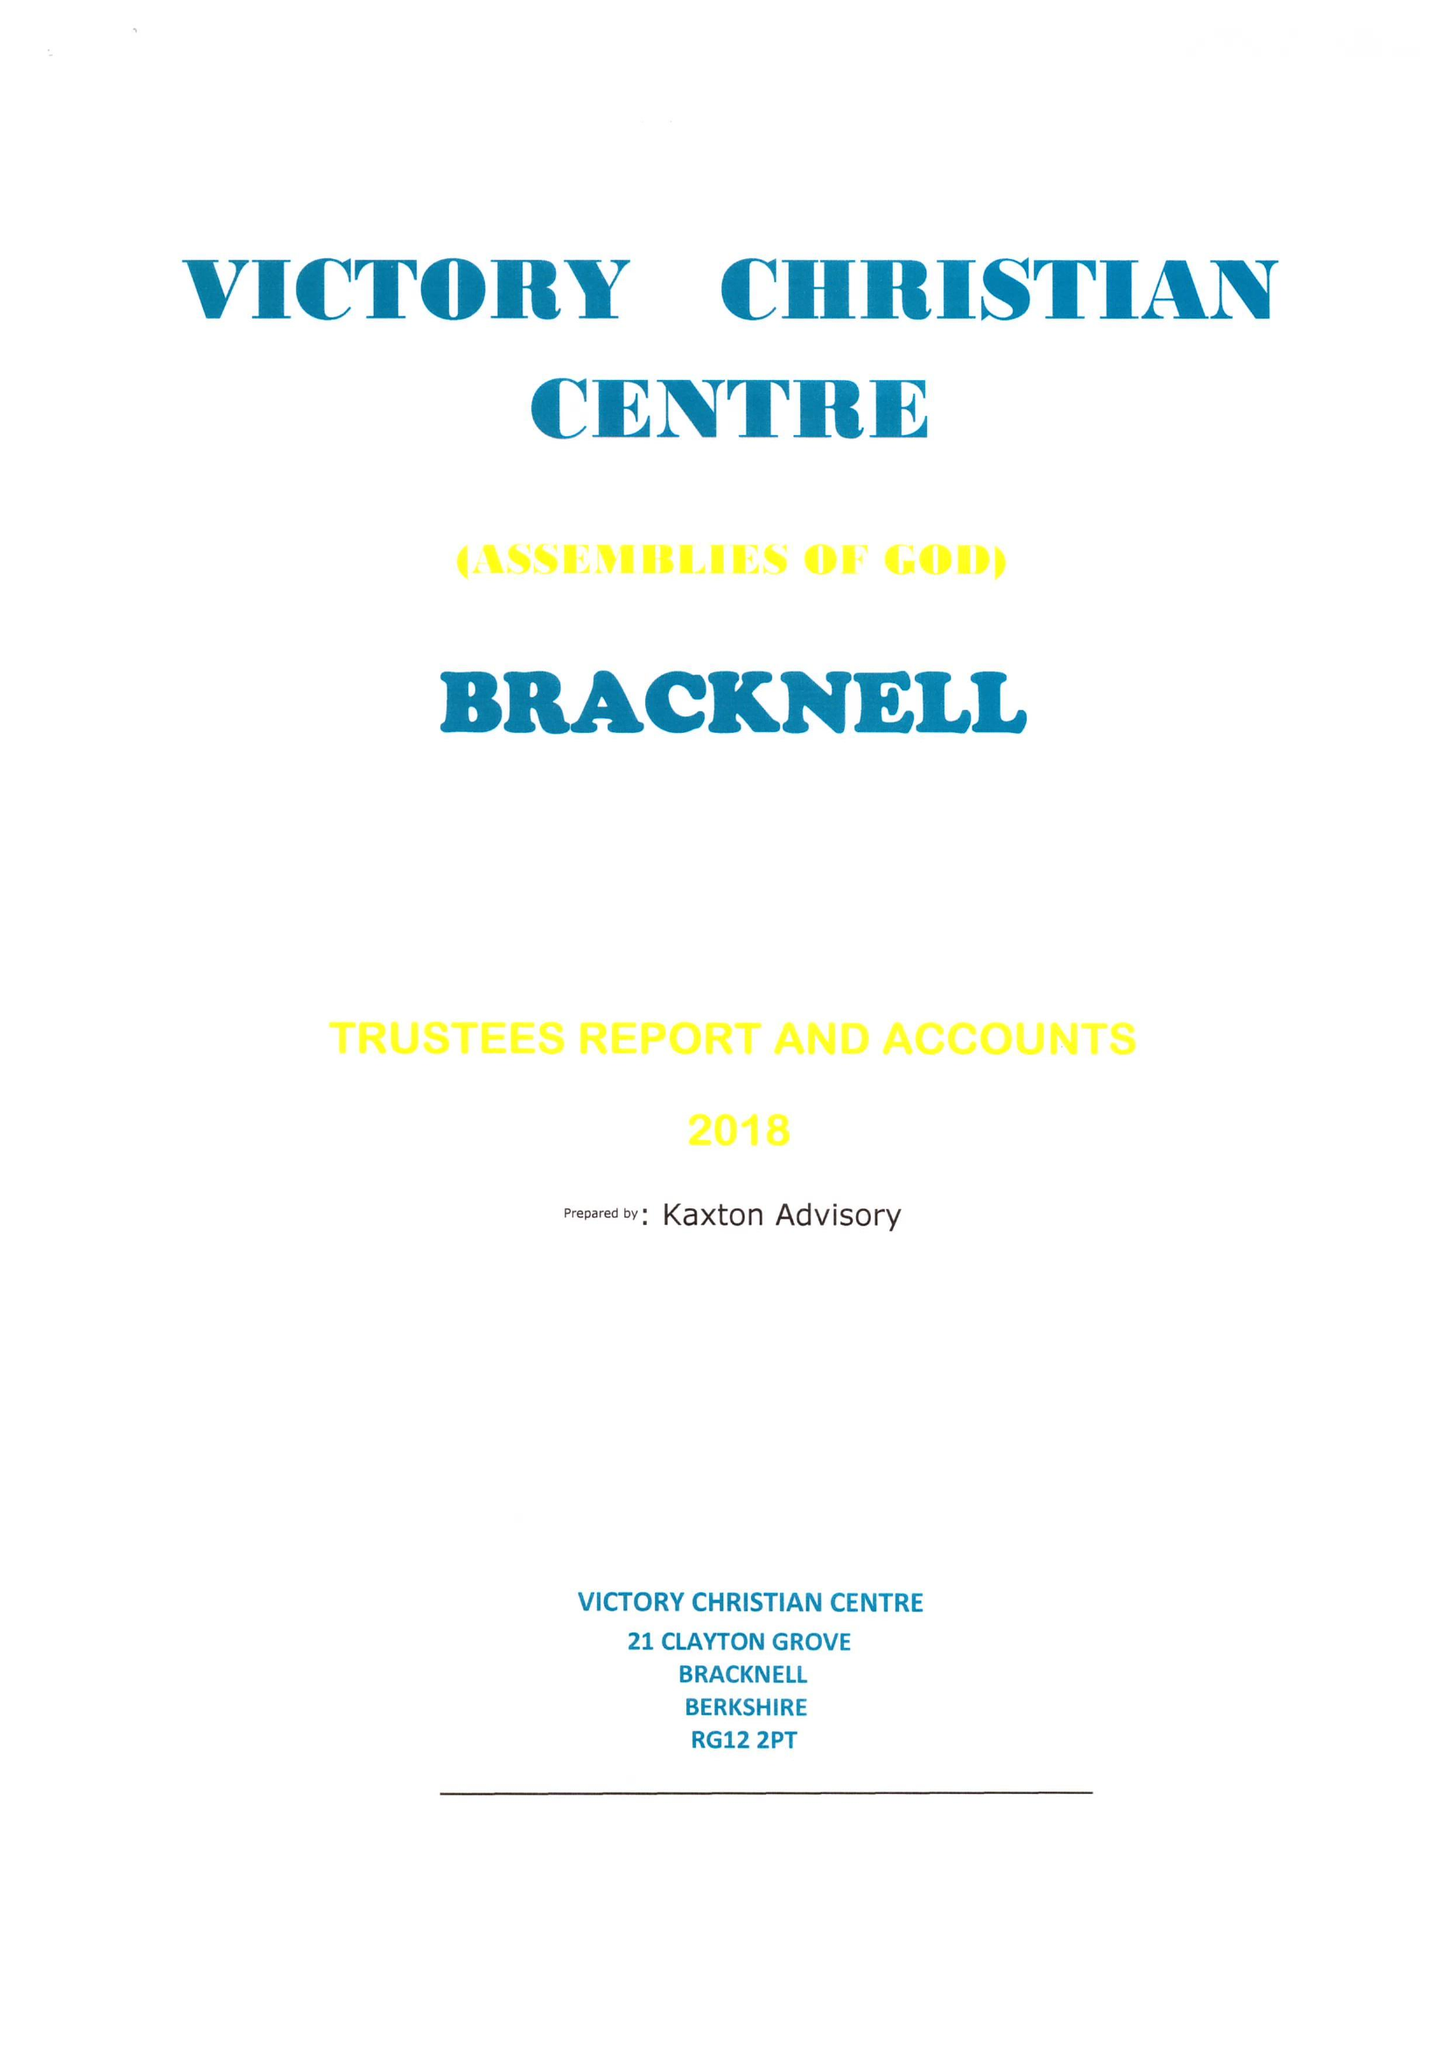What is the value for the charity_name?
Answer the question using a single word or phrase. Victory Christian Centre Assemblies Of God - Bracknell 